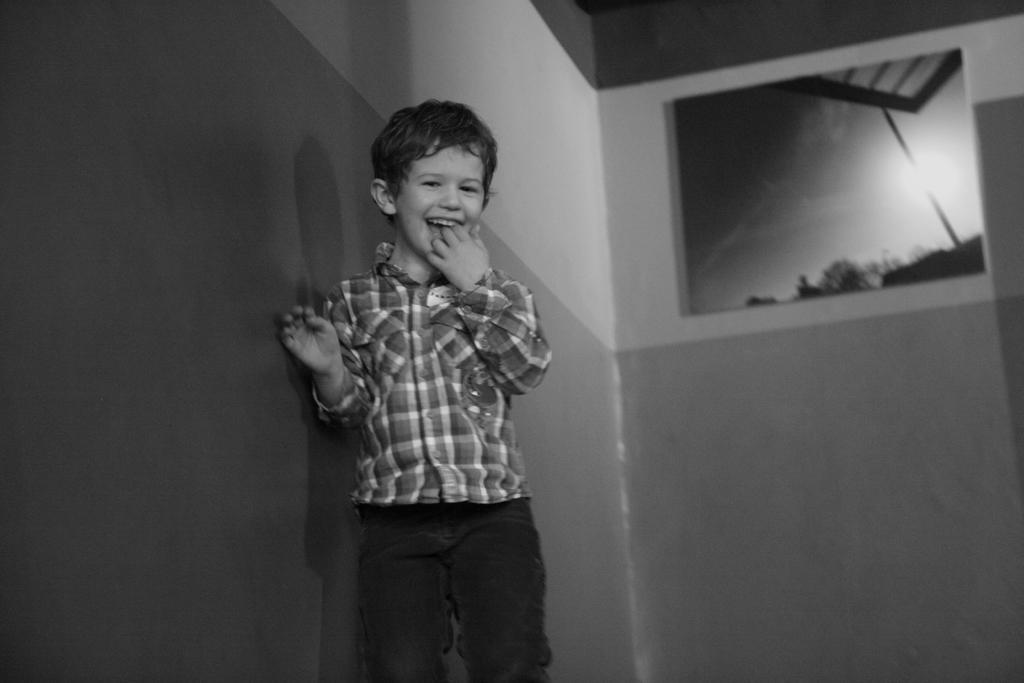Describe this image in one or two sentences. In this image I can see the black and white picture of a boy wearing shirt and pant is standing. In the background I can see the wall and I can see few trees and the sky in a photograph which is attached to the wall. 